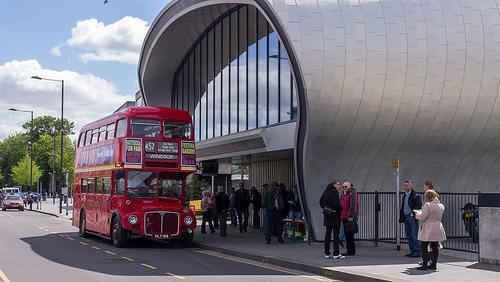Question: how many levels are on the bus?
Choices:
A. Three.
B. One.
C. Two.
D. Four.
Answer with the letter. Answer: C Question: where are the people?
Choices:
A. Busy street .
B. A shopping area.
C. A market.
D. On sidewalk.
Answer with the letter. Answer: D Question: where are the clouds?
Choices:
A. In sky.
B. Above.
C. Floating away.
D. Darkening.
Answer with the letter. Answer: A Question: what color is the street?
Choices:
A. Black.
B. Gray.
C. White.
D. Tan.
Answer with the letter. Answer: B 